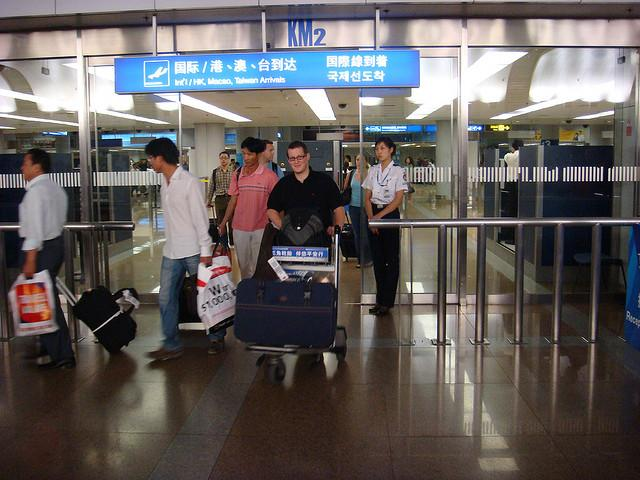What language is the sign in? chinese 